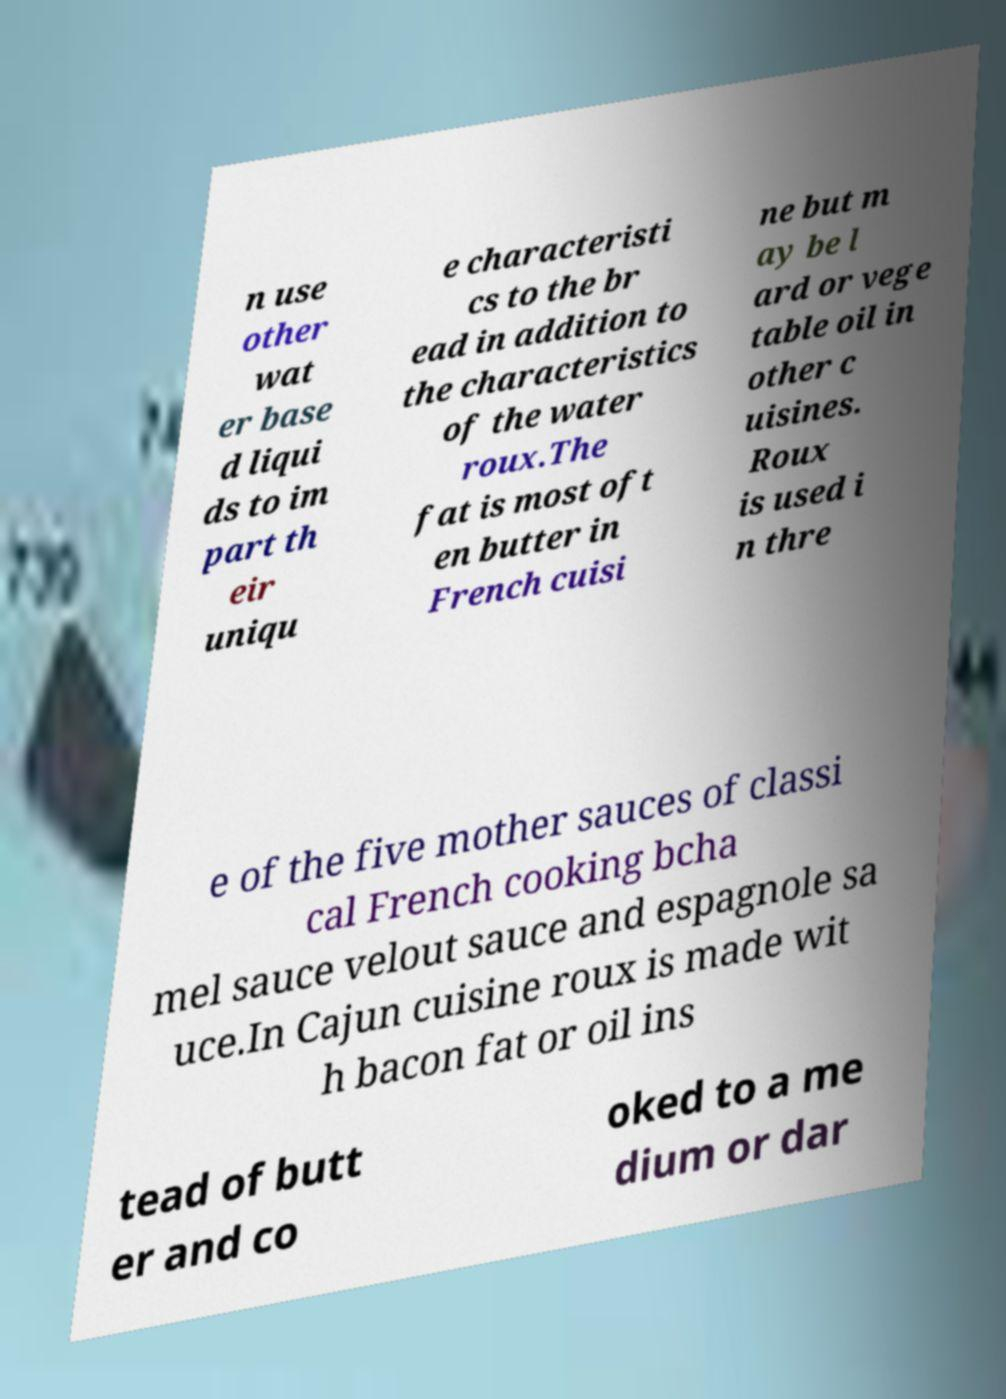Could you assist in decoding the text presented in this image and type it out clearly? n use other wat er base d liqui ds to im part th eir uniqu e characteristi cs to the br ead in addition to the characteristics of the water roux.The fat is most oft en butter in French cuisi ne but m ay be l ard or vege table oil in other c uisines. Roux is used i n thre e of the five mother sauces of classi cal French cooking bcha mel sauce velout sauce and espagnole sa uce.In Cajun cuisine roux is made wit h bacon fat or oil ins tead of butt er and co oked to a me dium or dar 